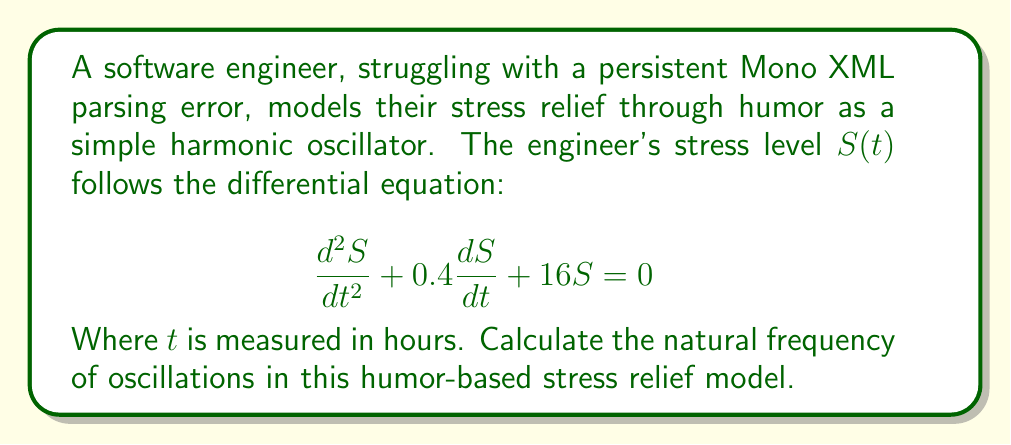Give your solution to this math problem. To find the natural frequency of oscillations, we need to analyze the given second-order linear differential equation:

$$\frac{d^2S}{dt^2} + 0.4\frac{dS}{dt} + 16S = 0$$

This equation is in the standard form of a damped harmonic oscillator:

$$\frac{d^2S}{dt^2} + 2\zeta\omega_n\frac{dS}{dt} + \omega_n^2S = 0$$

Where:
- $\zeta$ is the damping ratio
- $\omega_n$ is the natural frequency (in radians per hour)

Comparing our equation to the standard form, we can identify:

$2\zeta\omega_n = 0.4$
$\omega_n^2 = 16$

From the second equation, we can directly calculate $\omega_n$:

$$\omega_n = \sqrt{16} = 4\text{ rad/hour}$$

To convert this to Hz (cycles per hour), we divide by $2\pi$:

$$f_n = \frac{\omega_n}{2\pi} = \frac{4}{2\pi} \approx 0.6366\text{ Hz}$$

This frequency represents how often the engineer's stress level would naturally oscillate due to their humor-based coping mechanism while debugging the Mono XML parsing error.
Answer: The natural frequency of oscillations in the humor-based stress relief model is approximately 0.6366 Hz (cycles per hour). 